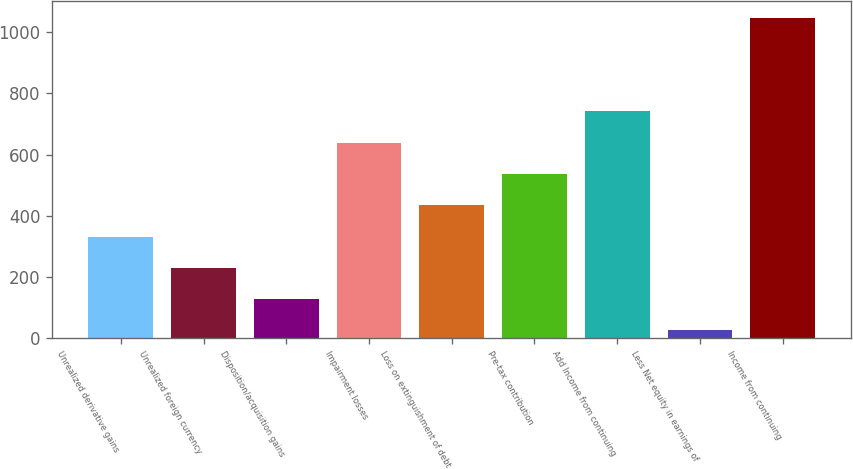Convert chart to OTSL. <chart><loc_0><loc_0><loc_500><loc_500><bar_chart><fcel>Unrealized derivative gains<fcel>Unrealized foreign currency<fcel>Disposition/acquisition gains<fcel>Impairment losses<fcel>Loss on extinguishment of debt<fcel>Pre-tax contribution<fcel>Add Income from continuing<fcel>Less Net equity in earnings of<fcel>Income from continuing<nl><fcel>331.9<fcel>229.6<fcel>127.3<fcel>638.8<fcel>434.2<fcel>536.5<fcel>741.1<fcel>25<fcel>1048<nl></chart> 